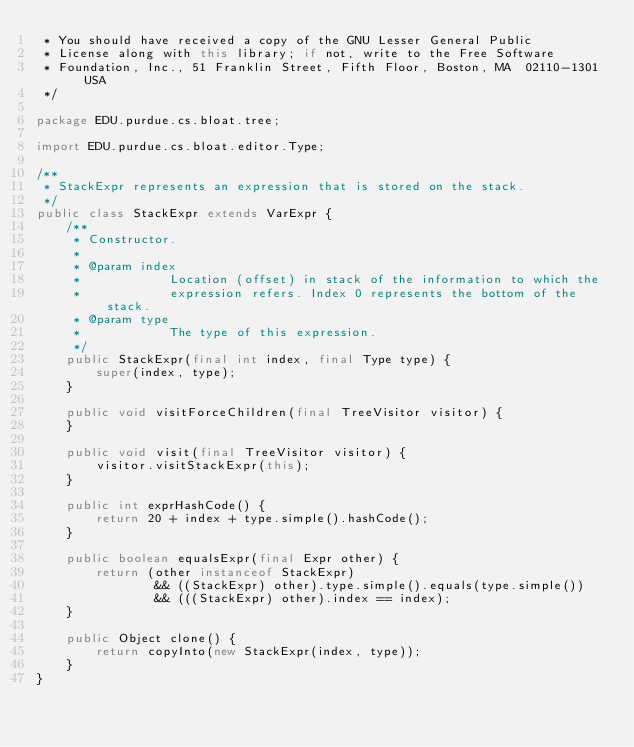Convert code to text. <code><loc_0><loc_0><loc_500><loc_500><_Java_> * You should have received a copy of the GNU Lesser General Public
 * License along with this library; if not, write to the Free Software
 * Foundation, Inc., 51 Franklin Street, Fifth Floor, Boston, MA  02110-1301  USA
 */

package EDU.purdue.cs.bloat.tree;

import EDU.purdue.cs.bloat.editor.Type;

/**
 * StackExpr represents an expression that is stored on the stack.
 */
public class StackExpr extends VarExpr {
	/**
	 * Constructor.
	 * 
	 * @param index
	 *            Location (offset) in stack of the information to which the
	 *            expression refers. Index 0 represents the bottom of the stack.
	 * @param type
	 *            The type of this expression.
	 */
	public StackExpr(final int index, final Type type) {
		super(index, type);
	}

	public void visitForceChildren(final TreeVisitor visitor) {
	}

	public void visit(final TreeVisitor visitor) {
		visitor.visitStackExpr(this);
	}

	public int exprHashCode() {
		return 20 + index + type.simple().hashCode();
	}

	public boolean equalsExpr(final Expr other) {
		return (other instanceof StackExpr)
				&& ((StackExpr) other).type.simple().equals(type.simple())
				&& (((StackExpr) other).index == index);
	}

	public Object clone() {
		return copyInto(new StackExpr(index, type));
	}
}
</code> 